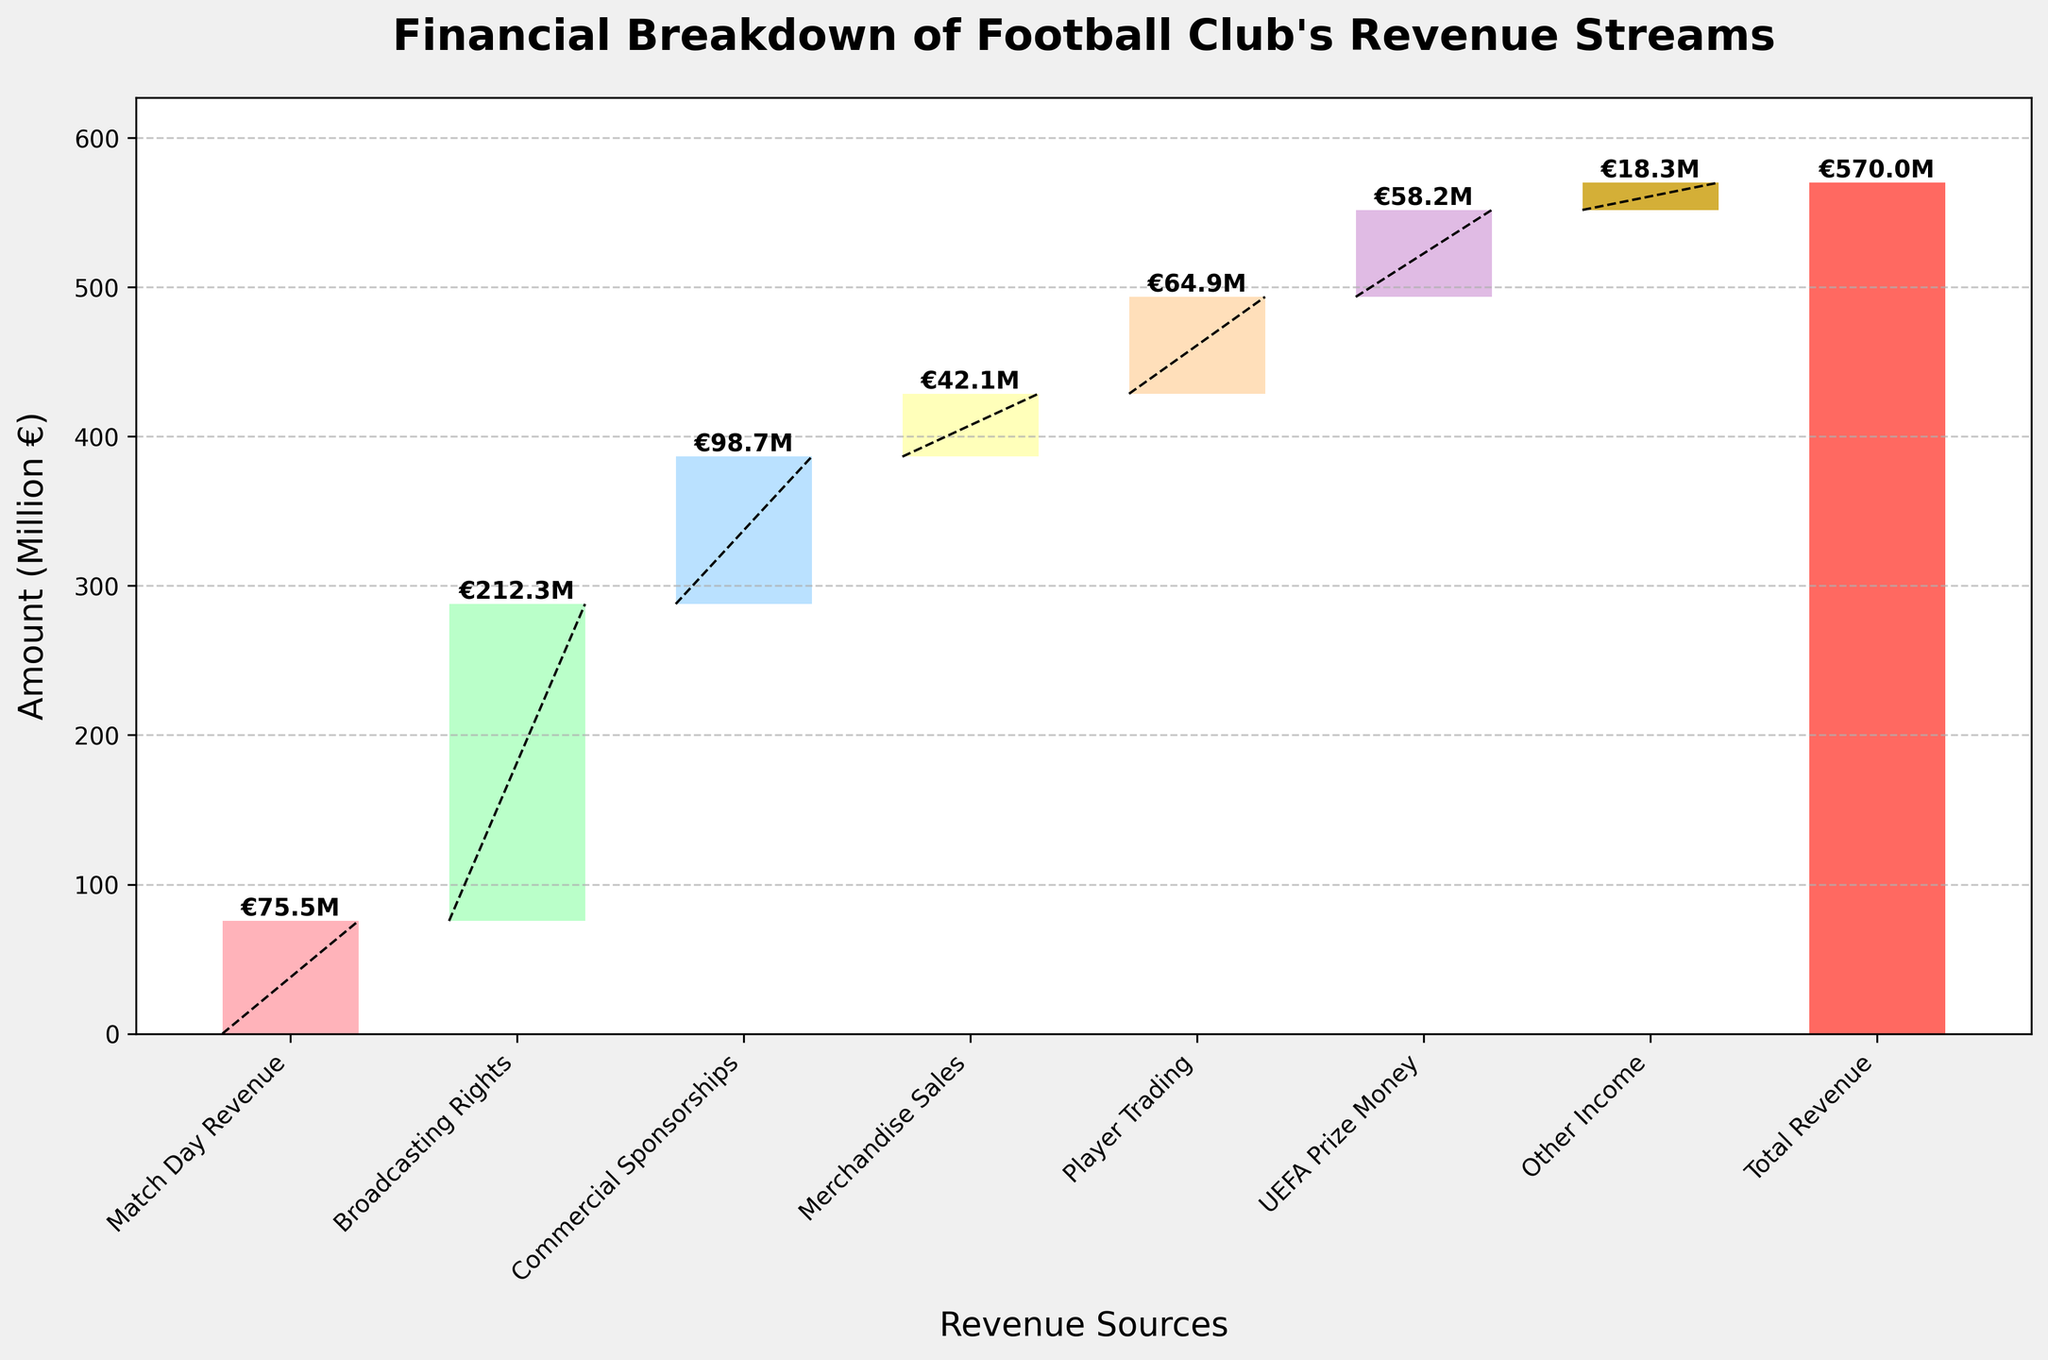What is the title of the plot? The title of the plot is located at the top and reads: "Financial Breakdown of Football Club's Revenue Streams".
Answer: Financial Breakdown of Football Club's Revenue Streams How many revenue sources are visualized in the plot, excluding the starting point and the total? To determine the number of revenue sources, count the distinct bars representing different categories in the plot, excluding "Start" and "Total Revenue".
Answer: 7 How much revenue is generated from Broadcasting Rights? Locate the bar labeled "Broadcasting Rights" and read the value directly next to it, which represents the amount generated from this category.
Answer: €212.3M What is the cumulative revenue after including Match Day Revenue and Broadcasting Rights? First, find Match Day Revenue (€75.5M) and Broadcasting Rights (€212.3M). Sum these values to get the cumulative revenue: 75.5 + 212.3 = 287.8.
Answer: €287.8M Which revenue source contributes the least to the total revenue? Examine the heights of all the bars and identify the shortest one, which represents "Other Income" at €18.3M.
Answer: Other Income What is the difference in revenue between Commercial Sponsorships and Merchandise Sales? Identify the values for Commercial Sponsorships (€98.7M) and Merchandise Sales (€42.1M). Subtract the latter from the former: 98.7 - 42.1 = 56.6.
Answer: €56.6M Is the revenue from UEFA Prize Money greater than that from Player Trading? Compare the values for UEFA Prize Money (€58.2M) and Player Trading (€64.9M). Since 58.2 is less than 64.9, UEFA Prize Money is not greater.
Answer: No What is the average revenue from all the sources excluding the starting point and total? Sum the revenue values from all categories except "Start" and "Total Revenue" (75.5 + 212.3 + 98.7 + 42.1 + 64.9 + 58.2 + 18.3 = 570). Divide this sum by 7 (the number of revenue sources): 570 / 7 = 81.43.
Answer: €81.43M What is the total revenue displayed on the plot? Look at the final bar labeled "Total Revenue" and read its value. The total revenue is displayed as €570M.
Answer: €570M What color is used to represent Player Trading? Observe the color of the bar labeled "Player Trading". It is displayed in a color similar to light orange or peach.
Answer: Light orange/peach 